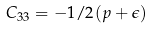<formula> <loc_0><loc_0><loc_500><loc_500>C _ { 3 3 } = - 1 / 2 ( p + \epsilon )</formula> 